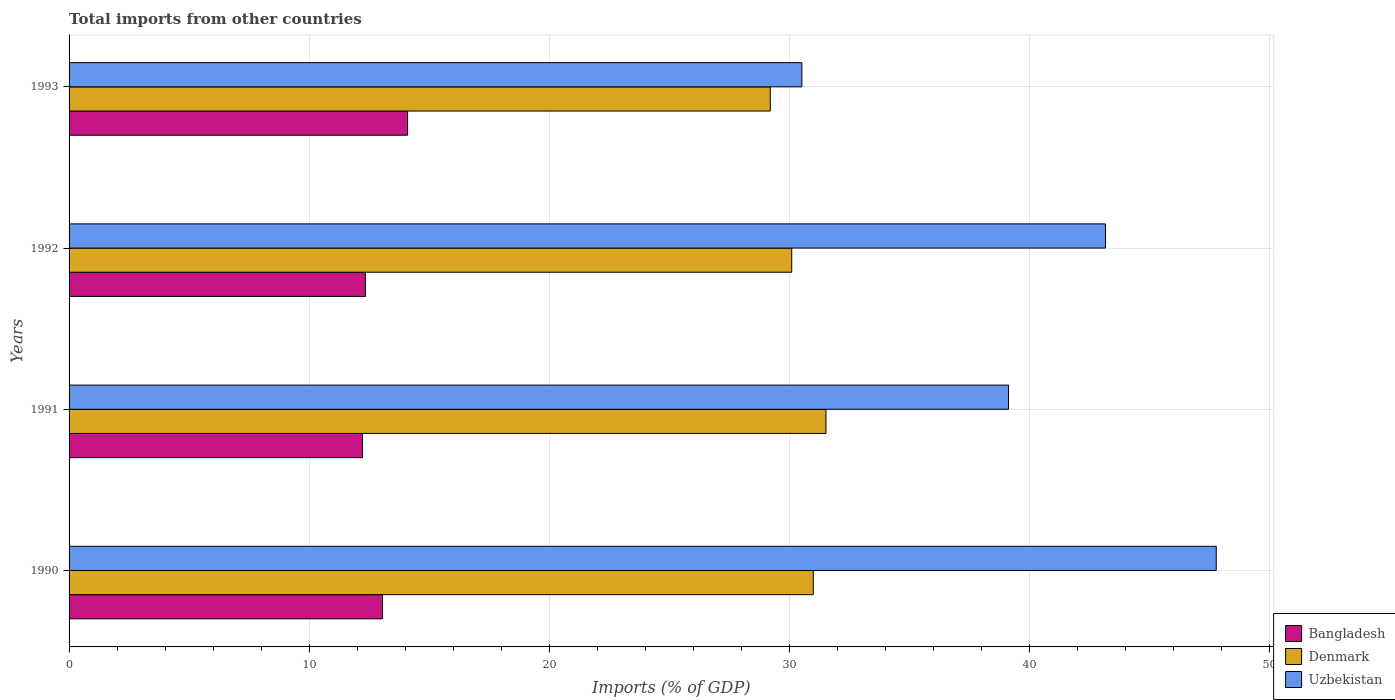How many different coloured bars are there?
Ensure brevity in your answer.  3. Are the number of bars per tick equal to the number of legend labels?
Provide a succinct answer. Yes. How many bars are there on the 2nd tick from the top?
Your answer should be very brief. 3. What is the total imports in Denmark in 1992?
Provide a succinct answer. 30.11. Across all years, what is the maximum total imports in Uzbekistan?
Keep it short and to the point. 47.8. Across all years, what is the minimum total imports in Uzbekistan?
Your response must be concise. 30.53. In which year was the total imports in Uzbekistan maximum?
Make the answer very short. 1990. What is the total total imports in Denmark in the graph?
Ensure brevity in your answer.  121.87. What is the difference between the total imports in Uzbekistan in 1990 and that in 1993?
Your response must be concise. 17.27. What is the difference between the total imports in Uzbekistan in 1990 and the total imports in Denmark in 1992?
Offer a terse response. 17.69. What is the average total imports in Uzbekistan per year?
Provide a short and direct response. 40.16. In the year 1990, what is the difference between the total imports in Denmark and total imports in Uzbekistan?
Your answer should be very brief. -16.79. What is the ratio of the total imports in Denmark in 1991 to that in 1992?
Your answer should be compact. 1.05. Is the total imports in Bangladesh in 1990 less than that in 1993?
Provide a succinct answer. Yes. Is the difference between the total imports in Denmark in 1990 and 1992 greater than the difference between the total imports in Uzbekistan in 1990 and 1992?
Your answer should be compact. No. What is the difference between the highest and the second highest total imports in Bangladesh?
Offer a terse response. 1.05. What is the difference between the highest and the lowest total imports in Uzbekistan?
Offer a terse response. 17.27. What does the 1st bar from the top in 1992 represents?
Ensure brevity in your answer.  Uzbekistan. What does the 3rd bar from the bottom in 1992 represents?
Your response must be concise. Uzbekistan. Is it the case that in every year, the sum of the total imports in Bangladesh and total imports in Denmark is greater than the total imports in Uzbekistan?
Give a very brief answer. No. How many bars are there?
Your answer should be very brief. 12. Are all the bars in the graph horizontal?
Offer a terse response. Yes. What is the difference between two consecutive major ticks on the X-axis?
Your answer should be very brief. 10. Does the graph contain any zero values?
Your answer should be compact. No. Where does the legend appear in the graph?
Make the answer very short. Bottom right. How are the legend labels stacked?
Offer a terse response. Vertical. What is the title of the graph?
Your answer should be compact. Total imports from other countries. Does "Afghanistan" appear as one of the legend labels in the graph?
Provide a succinct answer. No. What is the label or title of the X-axis?
Your answer should be compact. Imports (% of GDP). What is the Imports (% of GDP) in Bangladesh in 1990?
Offer a very short reply. 13.06. What is the Imports (% of GDP) in Denmark in 1990?
Provide a succinct answer. 31.01. What is the Imports (% of GDP) in Uzbekistan in 1990?
Give a very brief answer. 47.8. What is the Imports (% of GDP) in Bangladesh in 1991?
Offer a very short reply. 12.23. What is the Imports (% of GDP) in Denmark in 1991?
Keep it short and to the point. 31.54. What is the Imports (% of GDP) of Uzbekistan in 1991?
Your response must be concise. 39.14. What is the Imports (% of GDP) in Bangladesh in 1992?
Provide a short and direct response. 12.35. What is the Imports (% of GDP) of Denmark in 1992?
Offer a terse response. 30.11. What is the Imports (% of GDP) of Uzbekistan in 1992?
Provide a short and direct response. 43.18. What is the Imports (% of GDP) in Bangladesh in 1993?
Give a very brief answer. 14.1. What is the Imports (% of GDP) in Denmark in 1993?
Provide a short and direct response. 29.22. What is the Imports (% of GDP) in Uzbekistan in 1993?
Give a very brief answer. 30.53. Across all years, what is the maximum Imports (% of GDP) of Bangladesh?
Provide a succinct answer. 14.1. Across all years, what is the maximum Imports (% of GDP) in Denmark?
Provide a succinct answer. 31.54. Across all years, what is the maximum Imports (% of GDP) of Uzbekistan?
Provide a succinct answer. 47.8. Across all years, what is the minimum Imports (% of GDP) in Bangladesh?
Ensure brevity in your answer.  12.23. Across all years, what is the minimum Imports (% of GDP) of Denmark?
Provide a short and direct response. 29.22. Across all years, what is the minimum Imports (% of GDP) of Uzbekistan?
Ensure brevity in your answer.  30.53. What is the total Imports (% of GDP) of Bangladesh in the graph?
Provide a short and direct response. 51.74. What is the total Imports (% of GDP) of Denmark in the graph?
Offer a very short reply. 121.87. What is the total Imports (% of GDP) in Uzbekistan in the graph?
Your answer should be compact. 160.66. What is the difference between the Imports (% of GDP) of Bangladesh in 1990 and that in 1991?
Offer a very short reply. 0.83. What is the difference between the Imports (% of GDP) of Denmark in 1990 and that in 1991?
Provide a short and direct response. -0.53. What is the difference between the Imports (% of GDP) in Uzbekistan in 1990 and that in 1991?
Your response must be concise. 8.66. What is the difference between the Imports (% of GDP) of Bangladesh in 1990 and that in 1992?
Your response must be concise. 0.71. What is the difference between the Imports (% of GDP) in Denmark in 1990 and that in 1992?
Provide a succinct answer. 0.9. What is the difference between the Imports (% of GDP) of Uzbekistan in 1990 and that in 1992?
Your response must be concise. 4.62. What is the difference between the Imports (% of GDP) in Bangladesh in 1990 and that in 1993?
Ensure brevity in your answer.  -1.05. What is the difference between the Imports (% of GDP) in Denmark in 1990 and that in 1993?
Provide a short and direct response. 1.79. What is the difference between the Imports (% of GDP) in Uzbekistan in 1990 and that in 1993?
Ensure brevity in your answer.  17.27. What is the difference between the Imports (% of GDP) of Bangladesh in 1991 and that in 1992?
Ensure brevity in your answer.  -0.12. What is the difference between the Imports (% of GDP) of Denmark in 1991 and that in 1992?
Offer a very short reply. 1.43. What is the difference between the Imports (% of GDP) in Uzbekistan in 1991 and that in 1992?
Make the answer very short. -4.04. What is the difference between the Imports (% of GDP) in Bangladesh in 1991 and that in 1993?
Make the answer very short. -1.88. What is the difference between the Imports (% of GDP) of Denmark in 1991 and that in 1993?
Your response must be concise. 2.32. What is the difference between the Imports (% of GDP) in Uzbekistan in 1991 and that in 1993?
Your response must be concise. 8.61. What is the difference between the Imports (% of GDP) of Bangladesh in 1992 and that in 1993?
Your response must be concise. -1.76. What is the difference between the Imports (% of GDP) of Denmark in 1992 and that in 1993?
Give a very brief answer. 0.89. What is the difference between the Imports (% of GDP) of Uzbekistan in 1992 and that in 1993?
Provide a succinct answer. 12.65. What is the difference between the Imports (% of GDP) of Bangladesh in 1990 and the Imports (% of GDP) of Denmark in 1991?
Give a very brief answer. -18.48. What is the difference between the Imports (% of GDP) of Bangladesh in 1990 and the Imports (% of GDP) of Uzbekistan in 1991?
Offer a very short reply. -26.08. What is the difference between the Imports (% of GDP) of Denmark in 1990 and the Imports (% of GDP) of Uzbekistan in 1991?
Keep it short and to the point. -8.13. What is the difference between the Imports (% of GDP) in Bangladesh in 1990 and the Imports (% of GDP) in Denmark in 1992?
Your response must be concise. -17.05. What is the difference between the Imports (% of GDP) in Bangladesh in 1990 and the Imports (% of GDP) in Uzbekistan in 1992?
Keep it short and to the point. -30.13. What is the difference between the Imports (% of GDP) of Denmark in 1990 and the Imports (% of GDP) of Uzbekistan in 1992?
Your answer should be compact. -12.18. What is the difference between the Imports (% of GDP) of Bangladesh in 1990 and the Imports (% of GDP) of Denmark in 1993?
Give a very brief answer. -16.16. What is the difference between the Imports (% of GDP) in Bangladesh in 1990 and the Imports (% of GDP) in Uzbekistan in 1993?
Give a very brief answer. -17.48. What is the difference between the Imports (% of GDP) in Denmark in 1990 and the Imports (% of GDP) in Uzbekistan in 1993?
Your answer should be compact. 0.48. What is the difference between the Imports (% of GDP) in Bangladesh in 1991 and the Imports (% of GDP) in Denmark in 1992?
Offer a terse response. -17.88. What is the difference between the Imports (% of GDP) in Bangladesh in 1991 and the Imports (% of GDP) in Uzbekistan in 1992?
Offer a terse response. -30.96. What is the difference between the Imports (% of GDP) in Denmark in 1991 and the Imports (% of GDP) in Uzbekistan in 1992?
Provide a short and direct response. -11.65. What is the difference between the Imports (% of GDP) in Bangladesh in 1991 and the Imports (% of GDP) in Denmark in 1993?
Make the answer very short. -16.99. What is the difference between the Imports (% of GDP) in Bangladesh in 1991 and the Imports (% of GDP) in Uzbekistan in 1993?
Give a very brief answer. -18.31. What is the difference between the Imports (% of GDP) of Denmark in 1991 and the Imports (% of GDP) of Uzbekistan in 1993?
Provide a short and direct response. 1. What is the difference between the Imports (% of GDP) in Bangladesh in 1992 and the Imports (% of GDP) in Denmark in 1993?
Provide a short and direct response. -16.87. What is the difference between the Imports (% of GDP) in Bangladesh in 1992 and the Imports (% of GDP) in Uzbekistan in 1993?
Your response must be concise. -18.19. What is the difference between the Imports (% of GDP) of Denmark in 1992 and the Imports (% of GDP) of Uzbekistan in 1993?
Ensure brevity in your answer.  -0.42. What is the average Imports (% of GDP) in Bangladesh per year?
Your answer should be compact. 12.93. What is the average Imports (% of GDP) in Denmark per year?
Offer a terse response. 30.47. What is the average Imports (% of GDP) in Uzbekistan per year?
Your answer should be very brief. 40.16. In the year 1990, what is the difference between the Imports (% of GDP) in Bangladesh and Imports (% of GDP) in Denmark?
Provide a succinct answer. -17.95. In the year 1990, what is the difference between the Imports (% of GDP) of Bangladesh and Imports (% of GDP) of Uzbekistan?
Your answer should be very brief. -34.74. In the year 1990, what is the difference between the Imports (% of GDP) of Denmark and Imports (% of GDP) of Uzbekistan?
Make the answer very short. -16.79. In the year 1991, what is the difference between the Imports (% of GDP) in Bangladesh and Imports (% of GDP) in Denmark?
Ensure brevity in your answer.  -19.31. In the year 1991, what is the difference between the Imports (% of GDP) in Bangladesh and Imports (% of GDP) in Uzbekistan?
Give a very brief answer. -26.92. In the year 1991, what is the difference between the Imports (% of GDP) in Denmark and Imports (% of GDP) in Uzbekistan?
Provide a short and direct response. -7.61. In the year 1992, what is the difference between the Imports (% of GDP) of Bangladesh and Imports (% of GDP) of Denmark?
Your answer should be very brief. -17.76. In the year 1992, what is the difference between the Imports (% of GDP) of Bangladesh and Imports (% of GDP) of Uzbekistan?
Ensure brevity in your answer.  -30.84. In the year 1992, what is the difference between the Imports (% of GDP) of Denmark and Imports (% of GDP) of Uzbekistan?
Give a very brief answer. -13.07. In the year 1993, what is the difference between the Imports (% of GDP) of Bangladesh and Imports (% of GDP) of Denmark?
Ensure brevity in your answer.  -15.11. In the year 1993, what is the difference between the Imports (% of GDP) in Bangladesh and Imports (% of GDP) in Uzbekistan?
Your answer should be very brief. -16.43. In the year 1993, what is the difference between the Imports (% of GDP) in Denmark and Imports (% of GDP) in Uzbekistan?
Offer a terse response. -1.32. What is the ratio of the Imports (% of GDP) in Bangladesh in 1990 to that in 1991?
Ensure brevity in your answer.  1.07. What is the ratio of the Imports (% of GDP) of Denmark in 1990 to that in 1991?
Make the answer very short. 0.98. What is the ratio of the Imports (% of GDP) in Uzbekistan in 1990 to that in 1991?
Ensure brevity in your answer.  1.22. What is the ratio of the Imports (% of GDP) of Bangladesh in 1990 to that in 1992?
Your answer should be very brief. 1.06. What is the ratio of the Imports (% of GDP) of Denmark in 1990 to that in 1992?
Your response must be concise. 1.03. What is the ratio of the Imports (% of GDP) in Uzbekistan in 1990 to that in 1992?
Ensure brevity in your answer.  1.11. What is the ratio of the Imports (% of GDP) in Bangladesh in 1990 to that in 1993?
Give a very brief answer. 0.93. What is the ratio of the Imports (% of GDP) of Denmark in 1990 to that in 1993?
Provide a short and direct response. 1.06. What is the ratio of the Imports (% of GDP) of Uzbekistan in 1990 to that in 1993?
Ensure brevity in your answer.  1.57. What is the ratio of the Imports (% of GDP) in Bangladesh in 1991 to that in 1992?
Your answer should be very brief. 0.99. What is the ratio of the Imports (% of GDP) in Denmark in 1991 to that in 1992?
Offer a terse response. 1.05. What is the ratio of the Imports (% of GDP) in Uzbekistan in 1991 to that in 1992?
Give a very brief answer. 0.91. What is the ratio of the Imports (% of GDP) in Bangladesh in 1991 to that in 1993?
Your answer should be compact. 0.87. What is the ratio of the Imports (% of GDP) in Denmark in 1991 to that in 1993?
Provide a short and direct response. 1.08. What is the ratio of the Imports (% of GDP) of Uzbekistan in 1991 to that in 1993?
Your answer should be very brief. 1.28. What is the ratio of the Imports (% of GDP) of Bangladesh in 1992 to that in 1993?
Keep it short and to the point. 0.88. What is the ratio of the Imports (% of GDP) in Denmark in 1992 to that in 1993?
Your answer should be compact. 1.03. What is the ratio of the Imports (% of GDP) in Uzbekistan in 1992 to that in 1993?
Your answer should be very brief. 1.41. What is the difference between the highest and the second highest Imports (% of GDP) in Bangladesh?
Provide a succinct answer. 1.05. What is the difference between the highest and the second highest Imports (% of GDP) in Denmark?
Keep it short and to the point. 0.53. What is the difference between the highest and the second highest Imports (% of GDP) in Uzbekistan?
Your response must be concise. 4.62. What is the difference between the highest and the lowest Imports (% of GDP) of Bangladesh?
Your response must be concise. 1.88. What is the difference between the highest and the lowest Imports (% of GDP) in Denmark?
Offer a very short reply. 2.32. What is the difference between the highest and the lowest Imports (% of GDP) in Uzbekistan?
Offer a terse response. 17.27. 